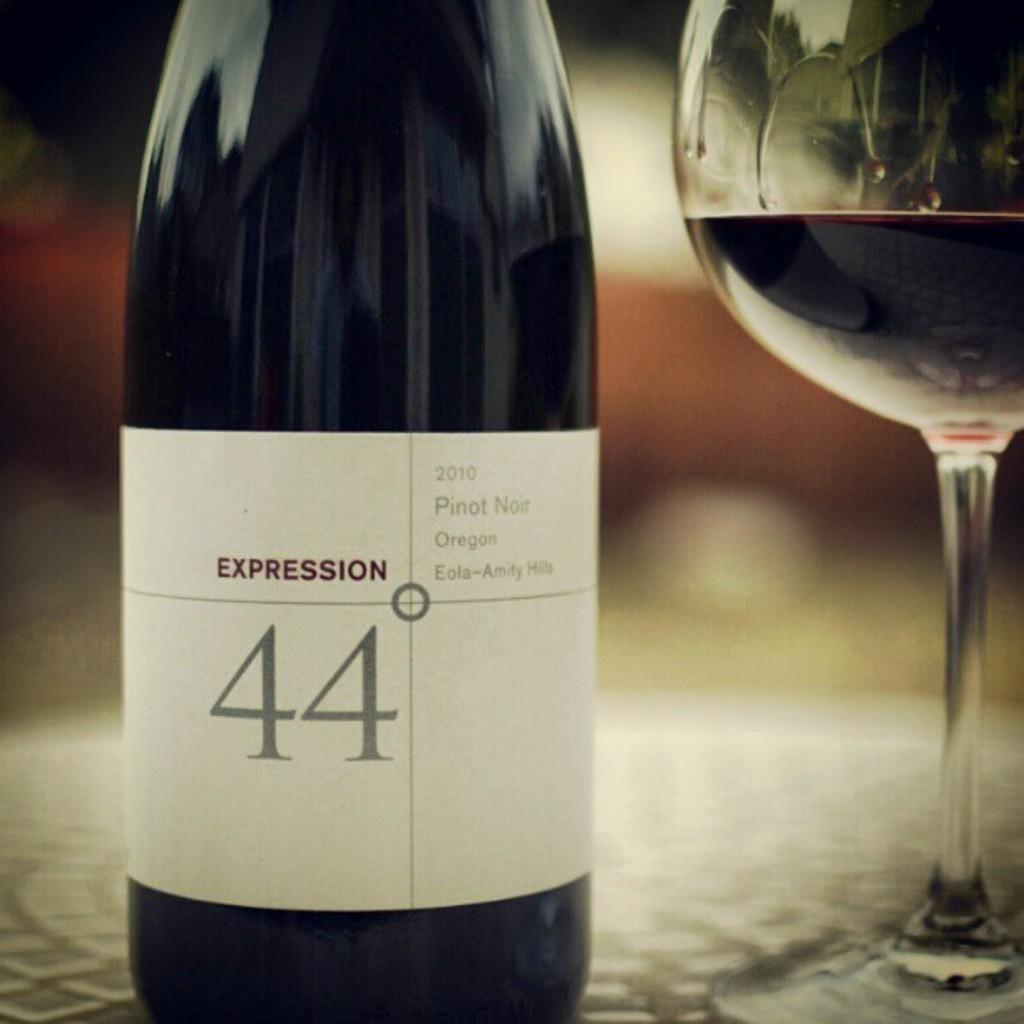Provide a one-sentence caption for the provided image. A bottle of Pinot Noir red wine branded with the name Expression 44 degrees. 